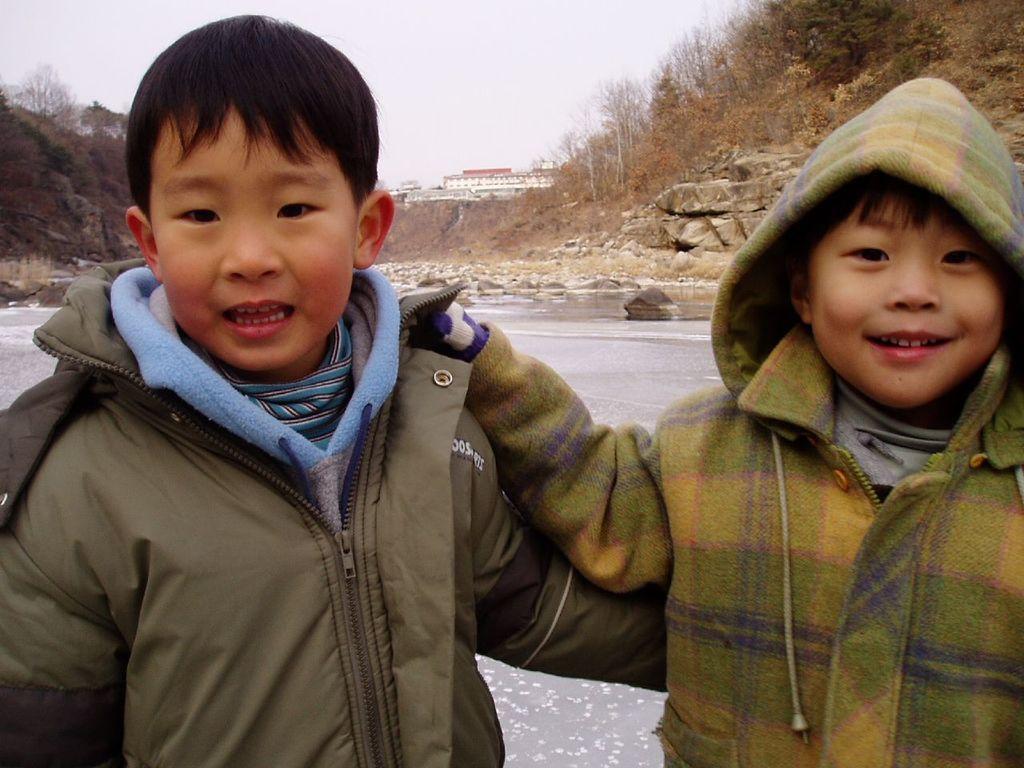Can you describe this image briefly? In the background we can see the sky, buildings, rocks and the water. This picture is mainly highlighted with the children wearing the jackets. 